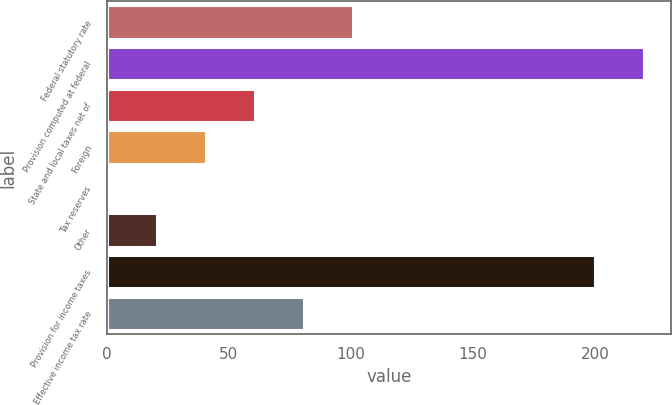Convert chart to OTSL. <chart><loc_0><loc_0><loc_500><loc_500><bar_chart><fcel>Federal statutory rate<fcel>Provision computed at federal<fcel>State and local taxes net of<fcel>Foreign<fcel>Tax reserves<fcel>Other<fcel>Provision for income taxes<fcel>Effective income tax rate<nl><fcel>100.8<fcel>220.24<fcel>60.72<fcel>40.68<fcel>0.6<fcel>20.64<fcel>200.2<fcel>80.76<nl></chart> 